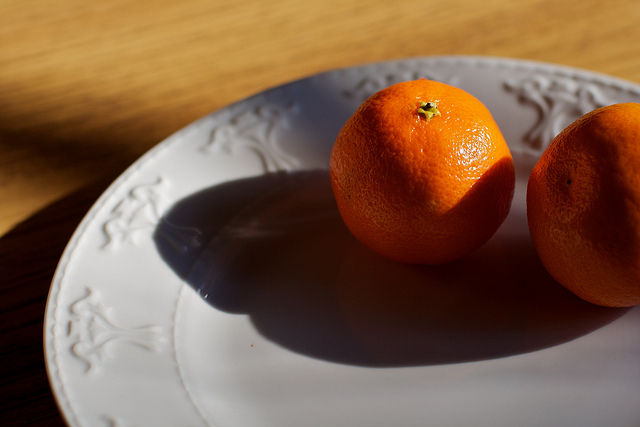Imagine a story behind these two oranges. In a quaint countryside kitchen, two oranges lay on a vintage plate, bathed in the golden hues of the morning sun. These fruits were freshly picked from the orchard just outside the cottage. Their fragrant aroma fills the air, hinting at the delicious marmalade that the grandmother will soon make, following a recipe passed down through generations. Their vibrant color echoes the joy and warmth of the family gatherings that this kitchen has witnessed over the years. 